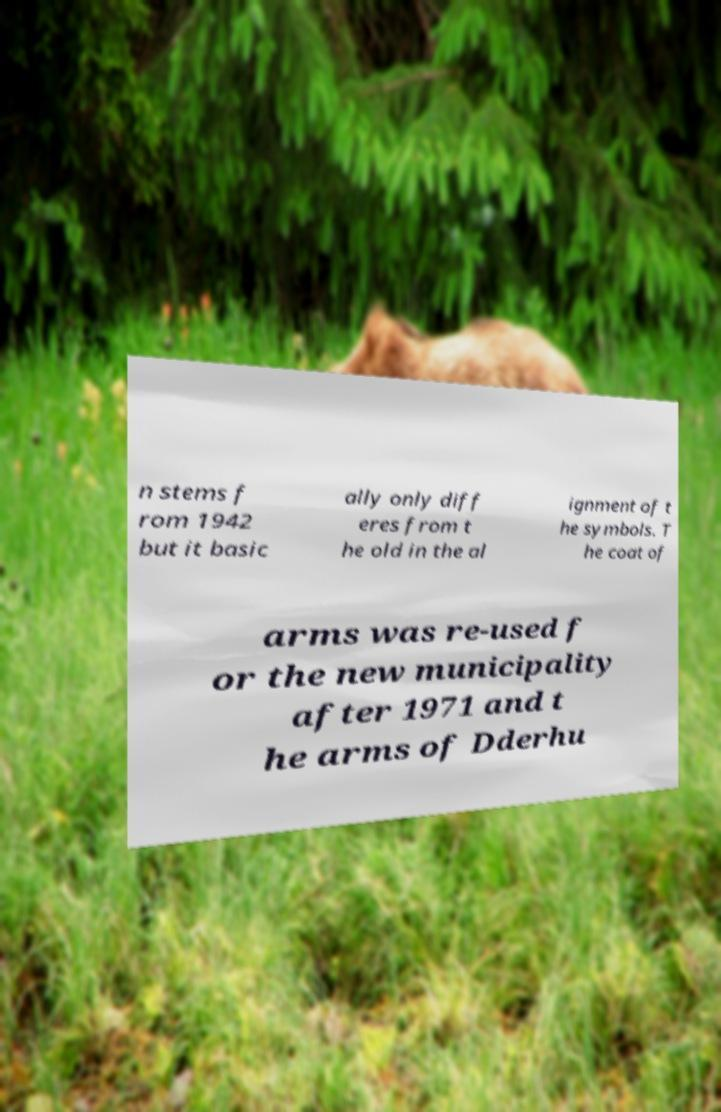For documentation purposes, I need the text within this image transcribed. Could you provide that? n stems f rom 1942 but it basic ally only diff eres from t he old in the al ignment of t he symbols. T he coat of arms was re-used f or the new municipality after 1971 and t he arms of Dderhu 